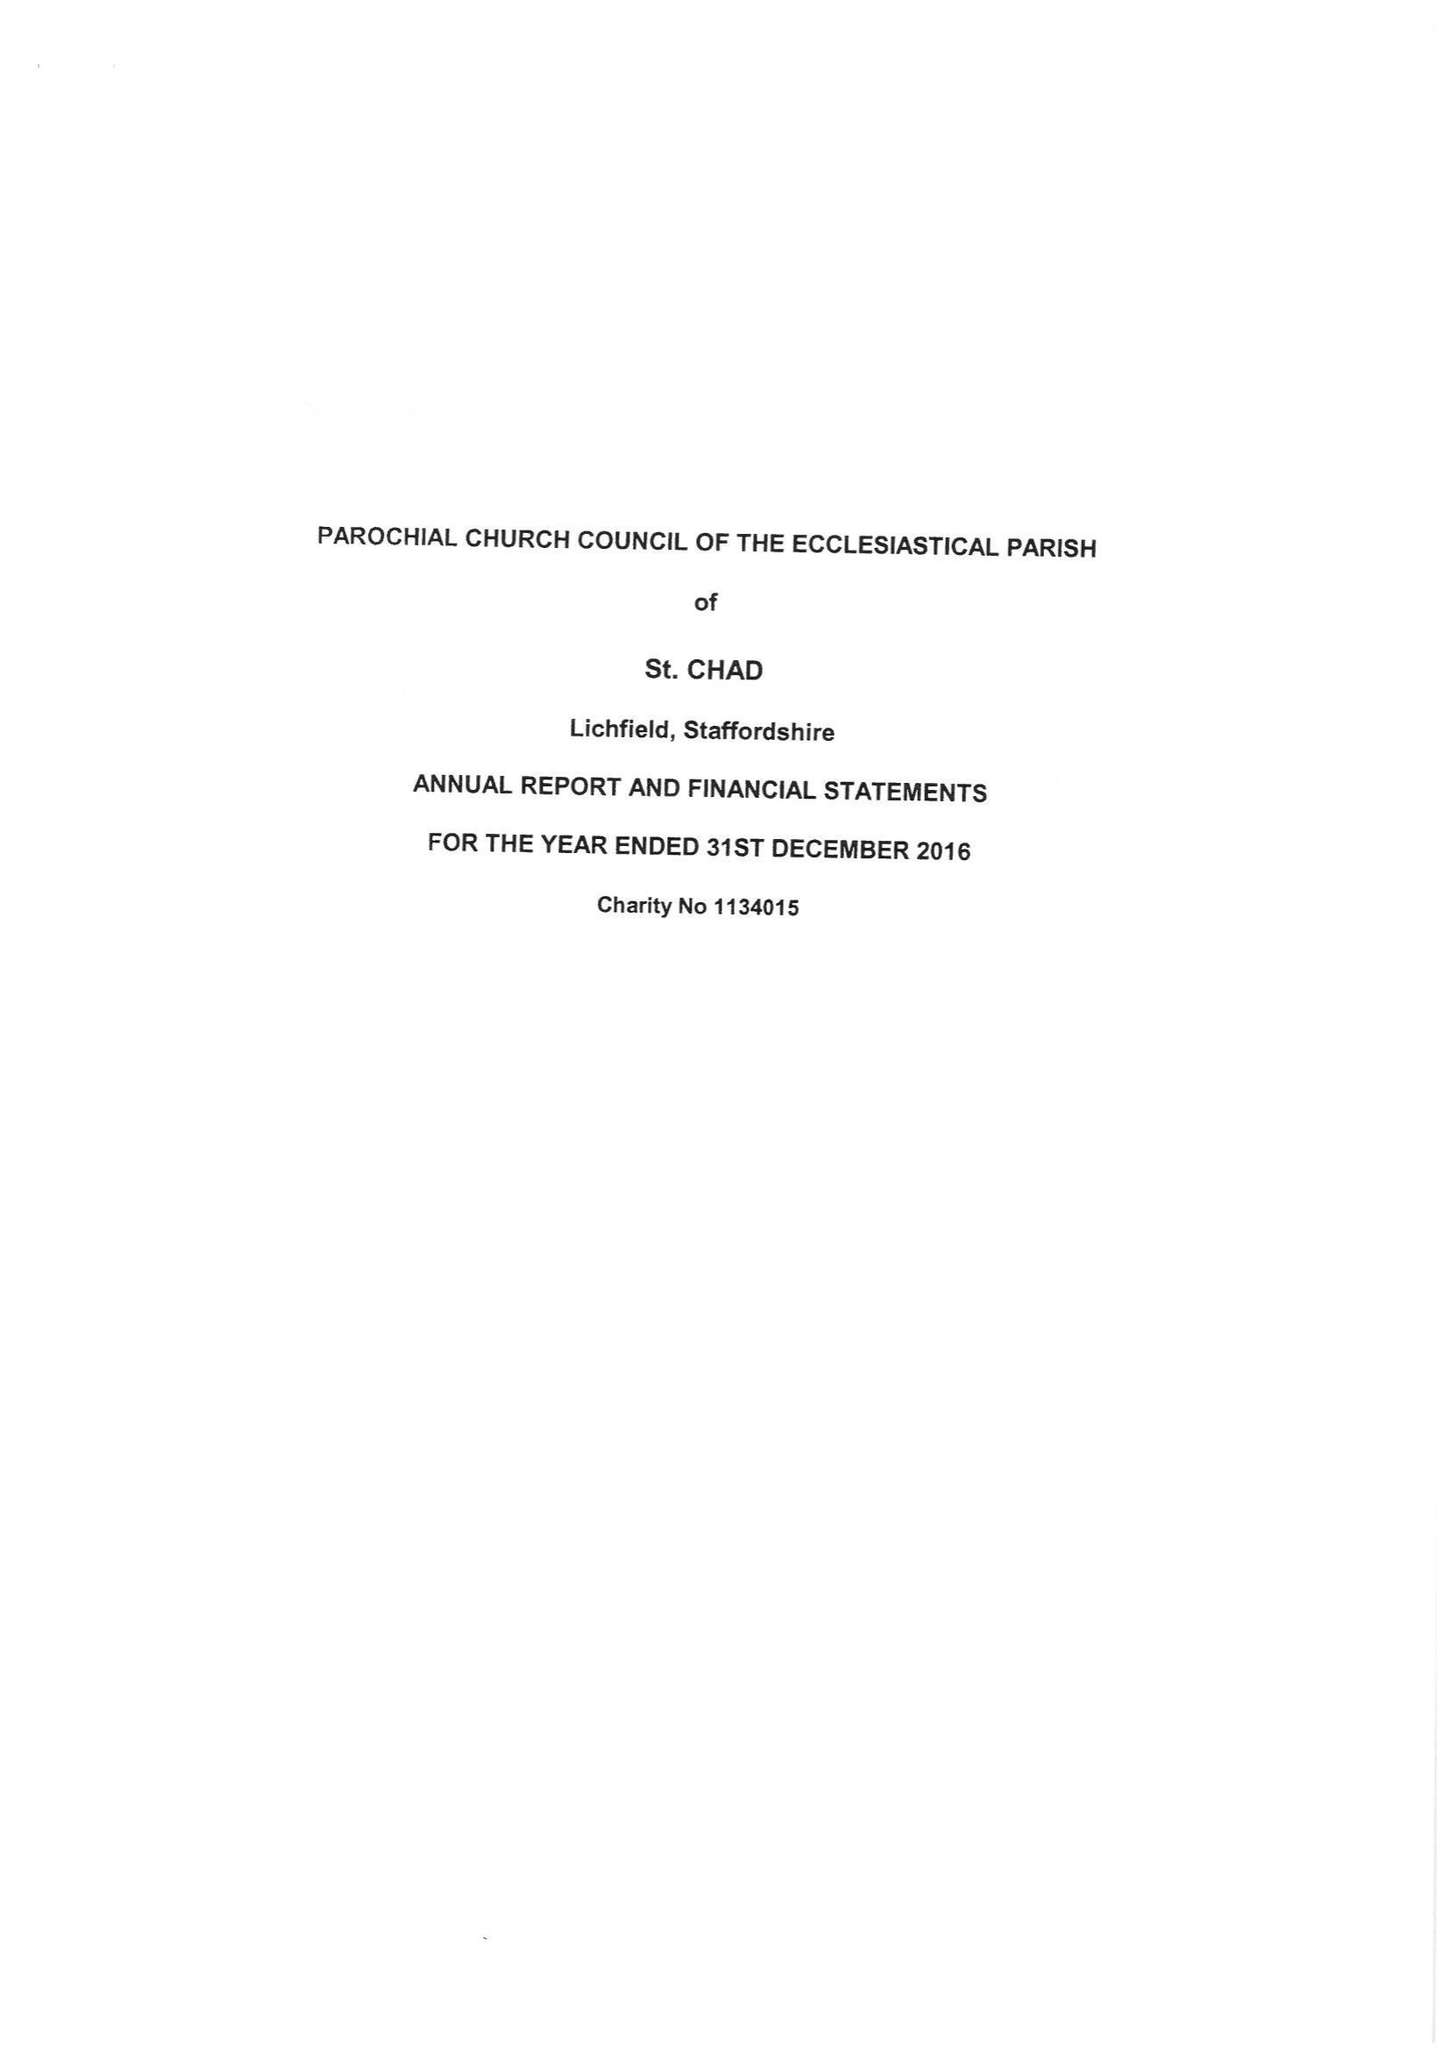What is the value for the spending_annually_in_british_pounds?
Answer the question using a single word or phrase. 189916.00 